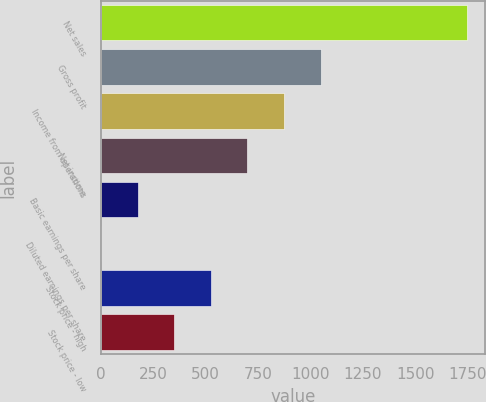Convert chart. <chart><loc_0><loc_0><loc_500><loc_500><bar_chart><fcel>Net sales<fcel>Gross profit<fcel>Income from operations<fcel>Net income<fcel>Basic earnings per share<fcel>Diluted earnings per share<fcel>Stock price - high<fcel>Stock price - low<nl><fcel>1746.6<fcel>1048.8<fcel>874.36<fcel>699.92<fcel>176.6<fcel>2.16<fcel>525.48<fcel>351.04<nl></chart> 